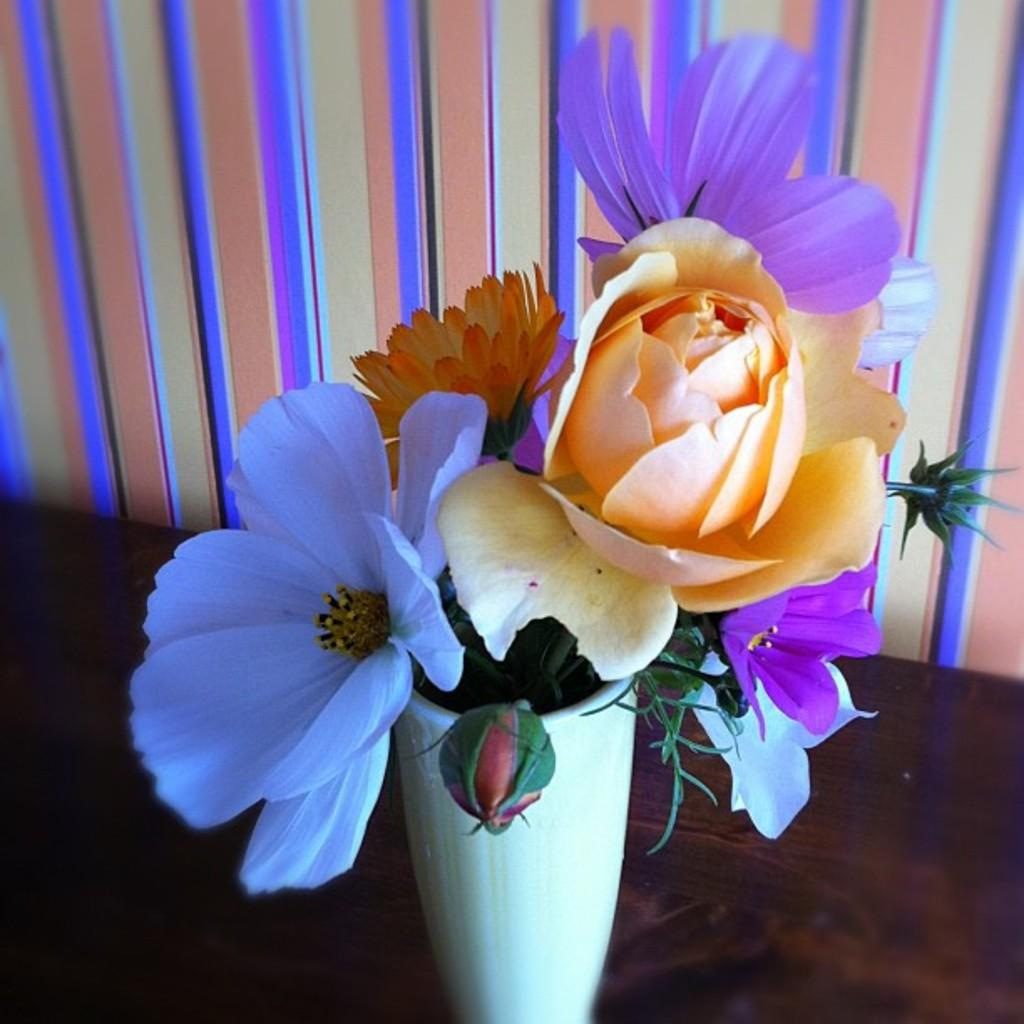What object is present in the image that typically holds plants? There is a flower pot in the image that typically holds plants. On what surface is the flower pot placed? The flower pot is on a wooden surface. What type of background can be seen in the image? There is a wall visible in the image. Can you see any hands reaching for the flower pot in the image? There are no hands visible in the image. What type of wilderness can be seen in the background of the image? There is no wilderness present in the image; it features a flower pot on a wooden surface with a wall in the background. 